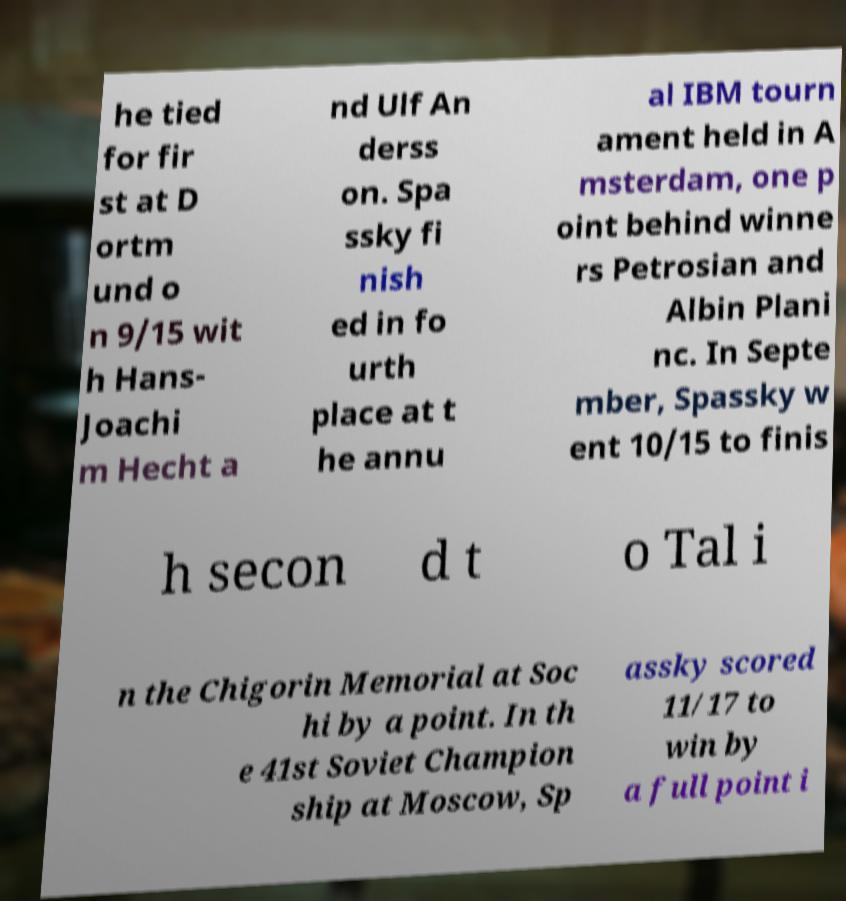For documentation purposes, I need the text within this image transcribed. Could you provide that? he tied for fir st at D ortm und o n 9/15 wit h Hans- Joachi m Hecht a nd Ulf An derss on. Spa ssky fi nish ed in fo urth place at t he annu al IBM tourn ament held in A msterdam, one p oint behind winne rs Petrosian and Albin Plani nc. In Septe mber, Spassky w ent 10/15 to finis h secon d t o Tal i n the Chigorin Memorial at Soc hi by a point. In th e 41st Soviet Champion ship at Moscow, Sp assky scored 11/17 to win by a full point i 